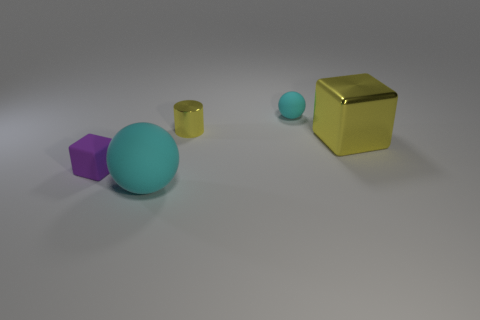There is a big thing that is the same material as the purple cube; what is its color?
Provide a succinct answer. Cyan. Are there more large metal things than large purple objects?
Provide a short and direct response. Yes. There is a thing that is both behind the large cyan object and on the left side of the small metal cylinder; how big is it?
Offer a very short reply. Small. There is a object that is the same color as the cylinder; what is its material?
Make the answer very short. Metal. Are there an equal number of tiny purple blocks in front of the big cyan matte object and small cylinders?
Make the answer very short. No. Do the yellow metal cylinder and the purple cube have the same size?
Your response must be concise. Yes. What is the color of the object that is in front of the small cyan rubber object and right of the tiny cylinder?
Provide a short and direct response. Yellow. There is a cyan thing that is in front of the cyan sphere that is behind the small purple rubber block; what is its material?
Keep it short and to the point. Rubber. What size is the other shiny object that is the same shape as the purple thing?
Your answer should be very brief. Large. Is the color of the big object on the left side of the large metal thing the same as the small matte ball?
Make the answer very short. Yes. 